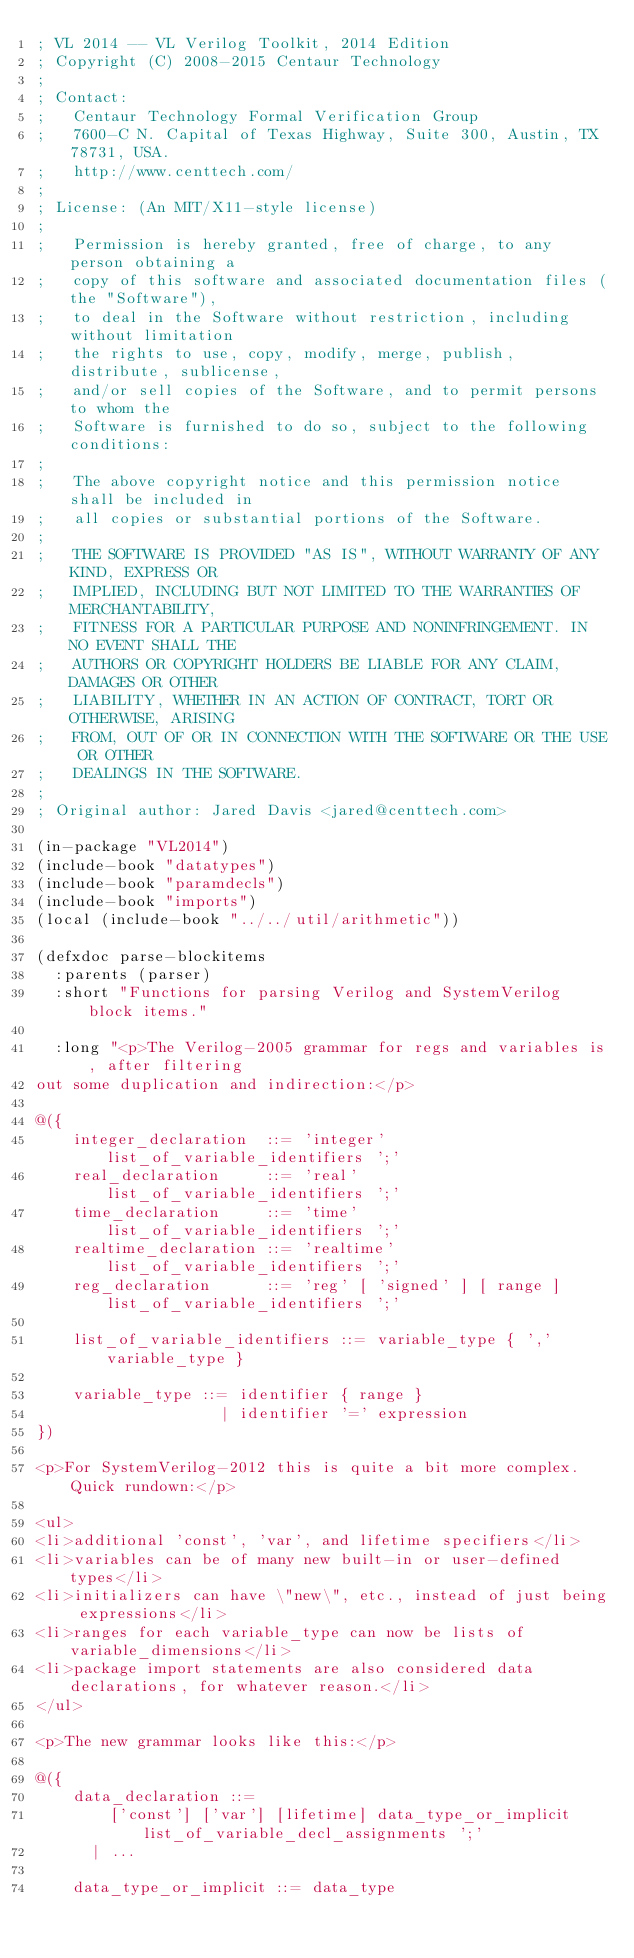Convert code to text. <code><loc_0><loc_0><loc_500><loc_500><_Lisp_>; VL 2014 -- VL Verilog Toolkit, 2014 Edition
; Copyright (C) 2008-2015 Centaur Technology
;
; Contact:
;   Centaur Technology Formal Verification Group
;   7600-C N. Capital of Texas Highway, Suite 300, Austin, TX 78731, USA.
;   http://www.centtech.com/
;
; License: (An MIT/X11-style license)
;
;   Permission is hereby granted, free of charge, to any person obtaining a
;   copy of this software and associated documentation files (the "Software"),
;   to deal in the Software without restriction, including without limitation
;   the rights to use, copy, modify, merge, publish, distribute, sublicense,
;   and/or sell copies of the Software, and to permit persons to whom the
;   Software is furnished to do so, subject to the following conditions:
;
;   The above copyright notice and this permission notice shall be included in
;   all copies or substantial portions of the Software.
;
;   THE SOFTWARE IS PROVIDED "AS IS", WITHOUT WARRANTY OF ANY KIND, EXPRESS OR
;   IMPLIED, INCLUDING BUT NOT LIMITED TO THE WARRANTIES OF MERCHANTABILITY,
;   FITNESS FOR A PARTICULAR PURPOSE AND NONINFRINGEMENT. IN NO EVENT SHALL THE
;   AUTHORS OR COPYRIGHT HOLDERS BE LIABLE FOR ANY CLAIM, DAMAGES OR OTHER
;   LIABILITY, WHETHER IN AN ACTION OF CONTRACT, TORT OR OTHERWISE, ARISING
;   FROM, OUT OF OR IN CONNECTION WITH THE SOFTWARE OR THE USE OR OTHER
;   DEALINGS IN THE SOFTWARE.
;
; Original author: Jared Davis <jared@centtech.com>

(in-package "VL2014")
(include-book "datatypes")
(include-book "paramdecls")
(include-book "imports")
(local (include-book "../../util/arithmetic"))

(defxdoc parse-blockitems
  :parents (parser)
  :short "Functions for parsing Verilog and SystemVerilog block items."

  :long "<p>The Verilog-2005 grammar for regs and variables is, after filtering
out some duplication and indirection:</p>

@({
    integer_declaration  ::= 'integer'  list_of_variable_identifiers ';'
    real_declaration     ::= 'real'     list_of_variable_identifiers ';'
    time_declaration     ::= 'time'     list_of_variable_identifiers ';'
    realtime_declaration ::= 'realtime' list_of_variable_identifiers ';'
    reg_declaration      ::= 'reg' [ 'signed' ] [ range ] list_of_variable_identifiers ';'

    list_of_variable_identifiers ::= variable_type { ',' variable_type }

    variable_type ::= identifier { range }
                    | identifier '=' expression
})

<p>For SystemVerilog-2012 this is quite a bit more complex.  Quick rundown:</p>

<ul>
<li>additional 'const', 'var', and lifetime specifiers</li>
<li>variables can be of many new built-in or user-defined types</li>
<li>initializers can have \"new\", etc., instead of just being expressions</li>
<li>ranges for each variable_type can now be lists of variable_dimensions</li>
<li>package import statements are also considered data declarations, for whatever reason.</li>
</ul>

<p>The new grammar looks like this:</p>

@({
    data_declaration ::=
        ['const'] ['var'] [lifetime] data_type_or_implicit list_of_variable_decl_assignments ';'
      | ...

    data_type_or_implicit ::= data_type</code> 